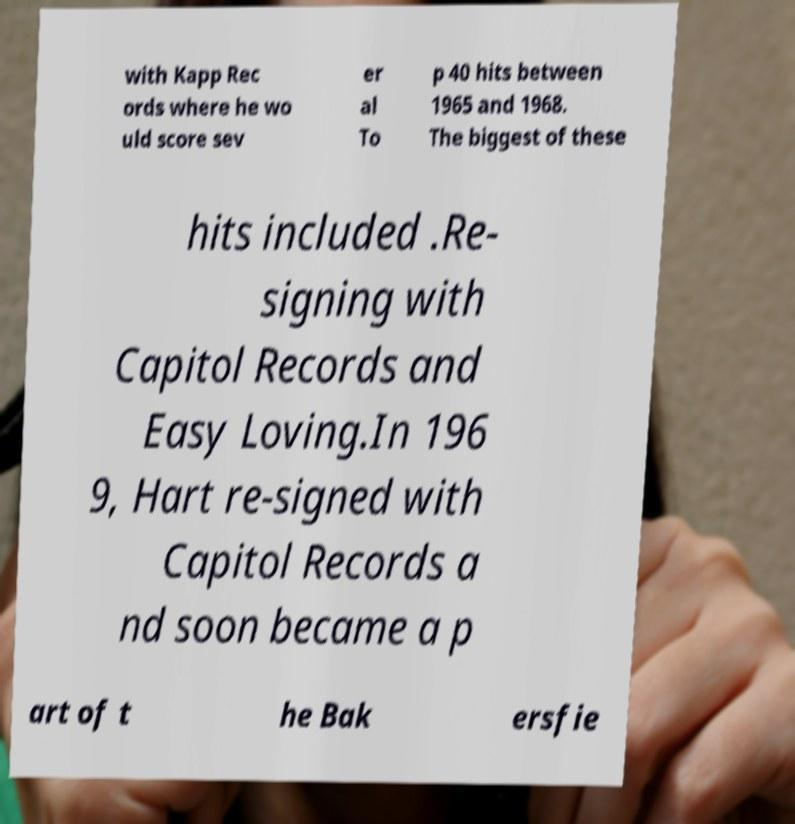What messages or text are displayed in this image? I need them in a readable, typed format. with Kapp Rec ords where he wo uld score sev er al To p 40 hits between 1965 and 1968. The biggest of these hits included .Re- signing with Capitol Records and Easy Loving.In 196 9, Hart re-signed with Capitol Records a nd soon became a p art of t he Bak ersfie 